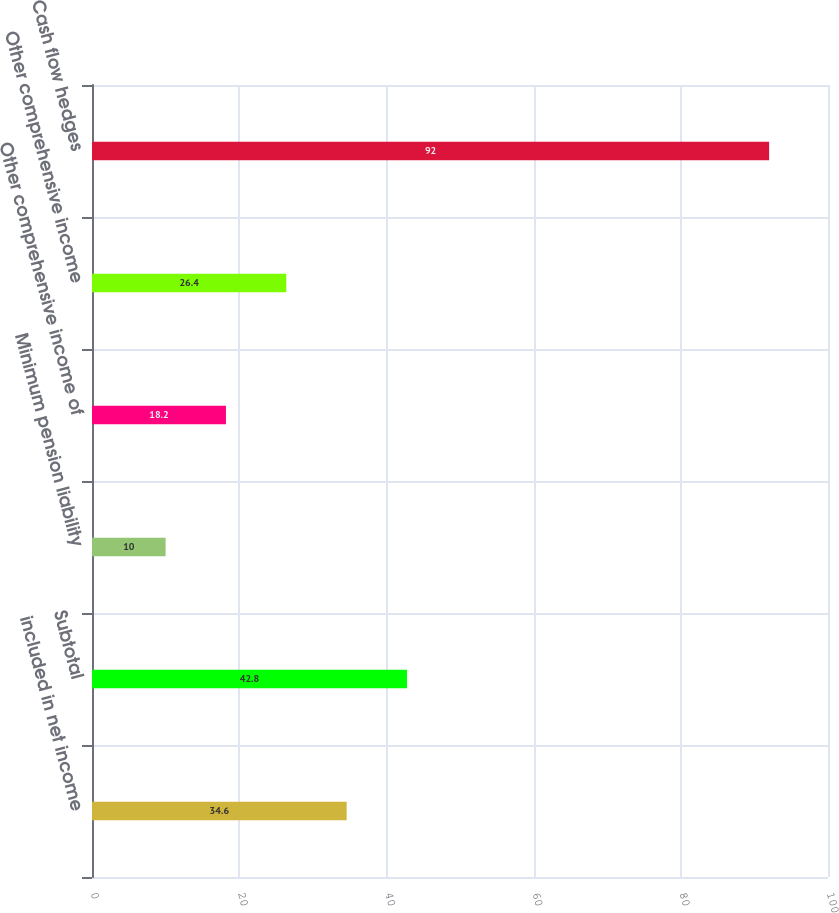<chart> <loc_0><loc_0><loc_500><loc_500><bar_chart><fcel>included in net income<fcel>Subtotal<fcel>Minimum pension liability<fcel>Other comprehensive income of<fcel>Other comprehensive income<fcel>Cash flow hedges<nl><fcel>34.6<fcel>42.8<fcel>10<fcel>18.2<fcel>26.4<fcel>92<nl></chart> 